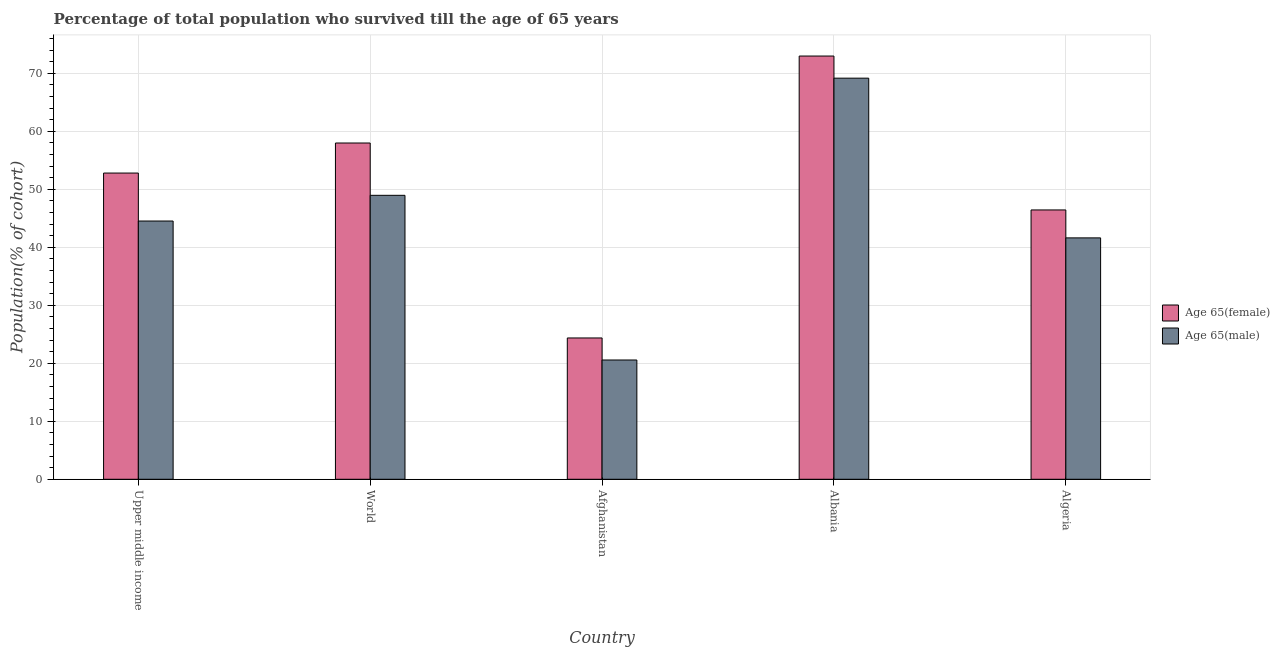How many different coloured bars are there?
Ensure brevity in your answer.  2. Are the number of bars per tick equal to the number of legend labels?
Your response must be concise. Yes. How many bars are there on the 1st tick from the left?
Your answer should be very brief. 2. What is the label of the 3rd group of bars from the left?
Your answer should be compact. Afghanistan. In how many cases, is the number of bars for a given country not equal to the number of legend labels?
Your answer should be very brief. 0. What is the percentage of male population who survived till age of 65 in World?
Offer a terse response. 48.96. Across all countries, what is the maximum percentage of male population who survived till age of 65?
Your response must be concise. 69.16. Across all countries, what is the minimum percentage of male population who survived till age of 65?
Your answer should be very brief. 20.57. In which country was the percentage of male population who survived till age of 65 maximum?
Make the answer very short. Albania. In which country was the percentage of female population who survived till age of 65 minimum?
Provide a succinct answer. Afghanistan. What is the total percentage of female population who survived till age of 65 in the graph?
Provide a succinct answer. 254.55. What is the difference between the percentage of female population who survived till age of 65 in Albania and that in World?
Offer a very short reply. 15. What is the difference between the percentage of female population who survived till age of 65 in Afghanistan and the percentage of male population who survived till age of 65 in Albania?
Your answer should be very brief. -44.79. What is the average percentage of female population who survived till age of 65 per country?
Your answer should be very brief. 50.91. What is the difference between the percentage of female population who survived till age of 65 and percentage of male population who survived till age of 65 in Upper middle income?
Your answer should be very brief. 8.27. In how many countries, is the percentage of female population who survived till age of 65 greater than 26 %?
Ensure brevity in your answer.  4. What is the ratio of the percentage of female population who survived till age of 65 in Albania to that in Upper middle income?
Your response must be concise. 1.38. Is the percentage of male population who survived till age of 65 in Albania less than that in Upper middle income?
Offer a very short reply. No. What is the difference between the highest and the second highest percentage of male population who survived till age of 65?
Give a very brief answer. 20.2. What is the difference between the highest and the lowest percentage of male population who survived till age of 65?
Keep it short and to the point. 48.59. In how many countries, is the percentage of male population who survived till age of 65 greater than the average percentage of male population who survived till age of 65 taken over all countries?
Provide a short and direct response. 2. What does the 2nd bar from the left in Afghanistan represents?
Ensure brevity in your answer.  Age 65(male). What does the 2nd bar from the right in World represents?
Make the answer very short. Age 65(female). Are all the bars in the graph horizontal?
Make the answer very short. No. What is the difference between two consecutive major ticks on the Y-axis?
Your answer should be very brief. 10. Does the graph contain any zero values?
Ensure brevity in your answer.  No. Does the graph contain grids?
Make the answer very short. Yes. How many legend labels are there?
Offer a terse response. 2. How are the legend labels stacked?
Offer a very short reply. Vertical. What is the title of the graph?
Your response must be concise. Percentage of total population who survived till the age of 65 years. Does "Male" appear as one of the legend labels in the graph?
Offer a terse response. No. What is the label or title of the X-axis?
Your answer should be very brief. Country. What is the label or title of the Y-axis?
Provide a succinct answer. Population(% of cohort). What is the Population(% of cohort) in Age 65(female) in Upper middle income?
Give a very brief answer. 52.8. What is the Population(% of cohort) in Age 65(male) in Upper middle income?
Your answer should be compact. 44.53. What is the Population(% of cohort) of Age 65(female) in World?
Keep it short and to the point. 57.98. What is the Population(% of cohort) in Age 65(male) in World?
Provide a short and direct response. 48.96. What is the Population(% of cohort) in Age 65(female) in Afghanistan?
Ensure brevity in your answer.  24.36. What is the Population(% of cohort) of Age 65(male) in Afghanistan?
Give a very brief answer. 20.57. What is the Population(% of cohort) in Age 65(female) in Albania?
Ensure brevity in your answer.  72.97. What is the Population(% of cohort) of Age 65(male) in Albania?
Provide a succinct answer. 69.16. What is the Population(% of cohort) of Age 65(female) in Algeria?
Make the answer very short. 46.44. What is the Population(% of cohort) of Age 65(male) in Algeria?
Make the answer very short. 41.62. Across all countries, what is the maximum Population(% of cohort) in Age 65(female)?
Your answer should be very brief. 72.97. Across all countries, what is the maximum Population(% of cohort) in Age 65(male)?
Give a very brief answer. 69.16. Across all countries, what is the minimum Population(% of cohort) in Age 65(female)?
Provide a short and direct response. 24.36. Across all countries, what is the minimum Population(% of cohort) in Age 65(male)?
Your answer should be very brief. 20.57. What is the total Population(% of cohort) in Age 65(female) in the graph?
Give a very brief answer. 254.55. What is the total Population(% of cohort) of Age 65(male) in the graph?
Your response must be concise. 224.83. What is the difference between the Population(% of cohort) of Age 65(female) in Upper middle income and that in World?
Your answer should be compact. -5.18. What is the difference between the Population(% of cohort) in Age 65(male) in Upper middle income and that in World?
Give a very brief answer. -4.43. What is the difference between the Population(% of cohort) in Age 65(female) in Upper middle income and that in Afghanistan?
Give a very brief answer. 28.43. What is the difference between the Population(% of cohort) in Age 65(male) in Upper middle income and that in Afghanistan?
Offer a very short reply. 23.96. What is the difference between the Population(% of cohort) in Age 65(female) in Upper middle income and that in Albania?
Your answer should be compact. -20.18. What is the difference between the Population(% of cohort) in Age 65(male) in Upper middle income and that in Albania?
Ensure brevity in your answer.  -24.63. What is the difference between the Population(% of cohort) of Age 65(female) in Upper middle income and that in Algeria?
Keep it short and to the point. 6.36. What is the difference between the Population(% of cohort) of Age 65(male) in Upper middle income and that in Algeria?
Your answer should be very brief. 2.91. What is the difference between the Population(% of cohort) in Age 65(female) in World and that in Afghanistan?
Offer a very short reply. 33.61. What is the difference between the Population(% of cohort) in Age 65(male) in World and that in Afghanistan?
Make the answer very short. 28.39. What is the difference between the Population(% of cohort) in Age 65(female) in World and that in Albania?
Provide a succinct answer. -15. What is the difference between the Population(% of cohort) of Age 65(male) in World and that in Albania?
Keep it short and to the point. -20.2. What is the difference between the Population(% of cohort) in Age 65(female) in World and that in Algeria?
Your answer should be very brief. 11.54. What is the difference between the Population(% of cohort) of Age 65(male) in World and that in Algeria?
Offer a very short reply. 7.34. What is the difference between the Population(% of cohort) of Age 65(female) in Afghanistan and that in Albania?
Make the answer very short. -48.61. What is the difference between the Population(% of cohort) in Age 65(male) in Afghanistan and that in Albania?
Provide a succinct answer. -48.59. What is the difference between the Population(% of cohort) of Age 65(female) in Afghanistan and that in Algeria?
Ensure brevity in your answer.  -22.07. What is the difference between the Population(% of cohort) of Age 65(male) in Afghanistan and that in Algeria?
Your answer should be compact. -21.06. What is the difference between the Population(% of cohort) of Age 65(female) in Albania and that in Algeria?
Keep it short and to the point. 26.54. What is the difference between the Population(% of cohort) of Age 65(male) in Albania and that in Algeria?
Give a very brief answer. 27.54. What is the difference between the Population(% of cohort) of Age 65(female) in Upper middle income and the Population(% of cohort) of Age 65(male) in World?
Provide a succinct answer. 3.84. What is the difference between the Population(% of cohort) of Age 65(female) in Upper middle income and the Population(% of cohort) of Age 65(male) in Afghanistan?
Ensure brevity in your answer.  32.23. What is the difference between the Population(% of cohort) of Age 65(female) in Upper middle income and the Population(% of cohort) of Age 65(male) in Albania?
Offer a terse response. -16.36. What is the difference between the Population(% of cohort) in Age 65(female) in Upper middle income and the Population(% of cohort) in Age 65(male) in Algeria?
Ensure brevity in your answer.  11.18. What is the difference between the Population(% of cohort) in Age 65(female) in World and the Population(% of cohort) in Age 65(male) in Afghanistan?
Provide a succinct answer. 37.41. What is the difference between the Population(% of cohort) in Age 65(female) in World and the Population(% of cohort) in Age 65(male) in Albania?
Offer a terse response. -11.18. What is the difference between the Population(% of cohort) of Age 65(female) in World and the Population(% of cohort) of Age 65(male) in Algeria?
Your answer should be very brief. 16.36. What is the difference between the Population(% of cohort) in Age 65(female) in Afghanistan and the Population(% of cohort) in Age 65(male) in Albania?
Your answer should be very brief. -44.79. What is the difference between the Population(% of cohort) of Age 65(female) in Afghanistan and the Population(% of cohort) of Age 65(male) in Algeria?
Ensure brevity in your answer.  -17.26. What is the difference between the Population(% of cohort) in Age 65(female) in Albania and the Population(% of cohort) in Age 65(male) in Algeria?
Your answer should be compact. 31.35. What is the average Population(% of cohort) in Age 65(female) per country?
Offer a very short reply. 50.91. What is the average Population(% of cohort) of Age 65(male) per country?
Provide a short and direct response. 44.97. What is the difference between the Population(% of cohort) in Age 65(female) and Population(% of cohort) in Age 65(male) in Upper middle income?
Provide a succinct answer. 8.27. What is the difference between the Population(% of cohort) of Age 65(female) and Population(% of cohort) of Age 65(male) in World?
Give a very brief answer. 9.02. What is the difference between the Population(% of cohort) in Age 65(female) and Population(% of cohort) in Age 65(male) in Afghanistan?
Offer a terse response. 3.8. What is the difference between the Population(% of cohort) in Age 65(female) and Population(% of cohort) in Age 65(male) in Albania?
Provide a succinct answer. 3.82. What is the difference between the Population(% of cohort) in Age 65(female) and Population(% of cohort) in Age 65(male) in Algeria?
Provide a short and direct response. 4.82. What is the ratio of the Population(% of cohort) of Age 65(female) in Upper middle income to that in World?
Provide a succinct answer. 0.91. What is the ratio of the Population(% of cohort) in Age 65(male) in Upper middle income to that in World?
Provide a short and direct response. 0.91. What is the ratio of the Population(% of cohort) in Age 65(female) in Upper middle income to that in Afghanistan?
Provide a short and direct response. 2.17. What is the ratio of the Population(% of cohort) of Age 65(male) in Upper middle income to that in Afghanistan?
Provide a short and direct response. 2.17. What is the ratio of the Population(% of cohort) in Age 65(female) in Upper middle income to that in Albania?
Offer a terse response. 0.72. What is the ratio of the Population(% of cohort) in Age 65(male) in Upper middle income to that in Albania?
Ensure brevity in your answer.  0.64. What is the ratio of the Population(% of cohort) of Age 65(female) in Upper middle income to that in Algeria?
Your answer should be very brief. 1.14. What is the ratio of the Population(% of cohort) of Age 65(male) in Upper middle income to that in Algeria?
Make the answer very short. 1.07. What is the ratio of the Population(% of cohort) of Age 65(female) in World to that in Afghanistan?
Give a very brief answer. 2.38. What is the ratio of the Population(% of cohort) in Age 65(male) in World to that in Afghanistan?
Provide a short and direct response. 2.38. What is the ratio of the Population(% of cohort) of Age 65(female) in World to that in Albania?
Your response must be concise. 0.79. What is the ratio of the Population(% of cohort) in Age 65(male) in World to that in Albania?
Your response must be concise. 0.71. What is the ratio of the Population(% of cohort) of Age 65(female) in World to that in Algeria?
Your answer should be very brief. 1.25. What is the ratio of the Population(% of cohort) of Age 65(male) in World to that in Algeria?
Provide a short and direct response. 1.18. What is the ratio of the Population(% of cohort) of Age 65(female) in Afghanistan to that in Albania?
Ensure brevity in your answer.  0.33. What is the ratio of the Population(% of cohort) of Age 65(male) in Afghanistan to that in Albania?
Keep it short and to the point. 0.3. What is the ratio of the Population(% of cohort) in Age 65(female) in Afghanistan to that in Algeria?
Offer a terse response. 0.52. What is the ratio of the Population(% of cohort) of Age 65(male) in Afghanistan to that in Algeria?
Keep it short and to the point. 0.49. What is the ratio of the Population(% of cohort) of Age 65(female) in Albania to that in Algeria?
Your answer should be compact. 1.57. What is the ratio of the Population(% of cohort) in Age 65(male) in Albania to that in Algeria?
Ensure brevity in your answer.  1.66. What is the difference between the highest and the second highest Population(% of cohort) in Age 65(female)?
Ensure brevity in your answer.  15. What is the difference between the highest and the second highest Population(% of cohort) of Age 65(male)?
Make the answer very short. 20.2. What is the difference between the highest and the lowest Population(% of cohort) of Age 65(female)?
Give a very brief answer. 48.61. What is the difference between the highest and the lowest Population(% of cohort) of Age 65(male)?
Give a very brief answer. 48.59. 